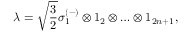Convert formula to latex. <formula><loc_0><loc_0><loc_500><loc_500>\lambda = \sqrt { \frac { 3 } { 2 } } \sigma _ { 1 } ^ { ( - ) } \otimes 1 _ { 2 } \otimes \dots \otimes 1 _ { 2 n + 1 } ,</formula> 